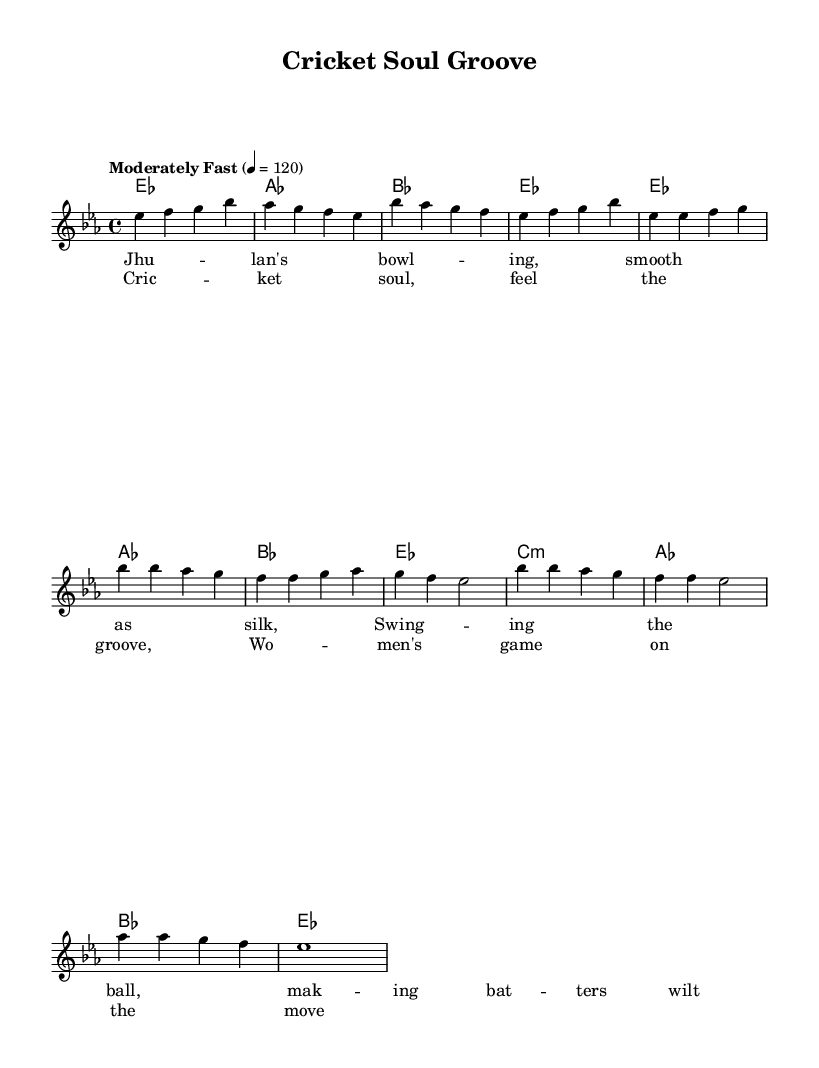What is the key signature of this music? The key signature is E flat major, indicated by the presence of three flats (B flat, E flat, and A flat). This can be recognized at the beginning of the sheet music where the key signature is shown.
Answer: E flat major What is the time signature of this music? The time signature is four-four, which is indicated by the notation that appears as a fraction at the beginning of the piece. This tells us that there are four beats per measure.
Answer: Four-four What is the tempo marking for this piece? The tempo marking is "Moderately Fast" at a rate of 120 beats per minute, indicated in the tempo text at the beginning of the score.
Answer: Moderately Fast, 120 How many measures are in the melody section? The melody section consists of eight measures, counting each line of musical notation before the harmonies begin.
Answer: Eight What is the mood conveyed by the chorus lyrics? The chorus lyrics convey a mood of empowerment and celebration, reflecting the theme of women's cricket making progress and thriving, as seen in the text.
Answer: Empowerment In which section of the music do the lyrics about Jhulan appear? The lyrics about Jhulan appear in the verse section, specifically referencing her bowling prowess and impact on the game, as seen in the designated lyric staves.
Answer: Verse How does the rhythm support the groove characteristic of Funky Soul? The rhythm contains syncopated elements with a strong backbeat, typical of Funky Soul, which can be observed in the overall structure and pattern of the melody and harmonies.
Answer: Syncopated 